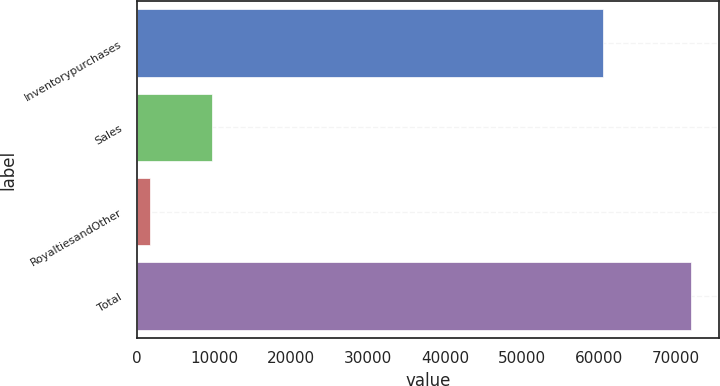Convert chart to OTSL. <chart><loc_0><loc_0><loc_500><loc_500><bar_chart><fcel>Inventorypurchases<fcel>Sales<fcel>RoyaltiesandOther<fcel>Total<nl><fcel>60520<fcel>9775<fcel>1633<fcel>71928<nl></chart> 